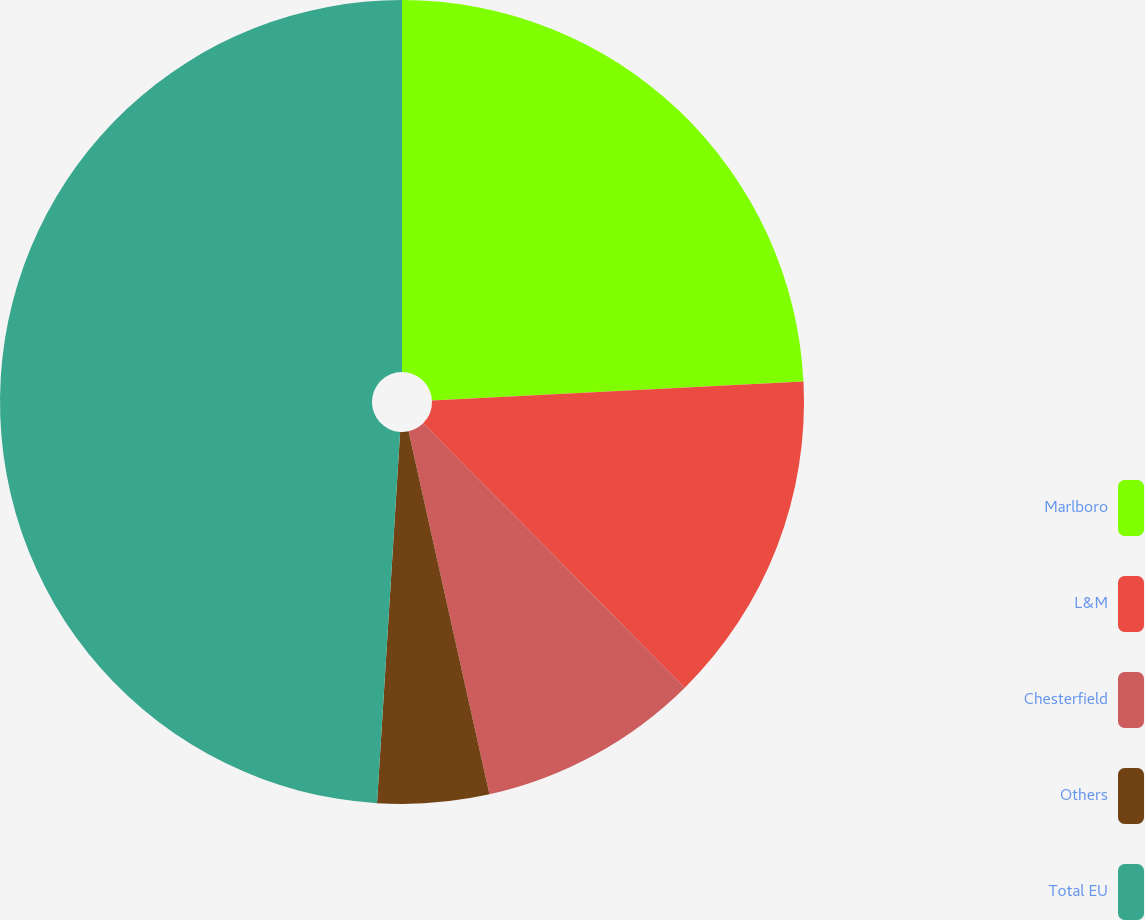Convert chart. <chart><loc_0><loc_0><loc_500><loc_500><pie_chart><fcel>Marlboro<fcel>L&M<fcel>Chesterfield<fcel>Others<fcel>Total EU<nl><fcel>24.19%<fcel>13.39%<fcel>8.93%<fcel>4.48%<fcel>49.01%<nl></chart> 